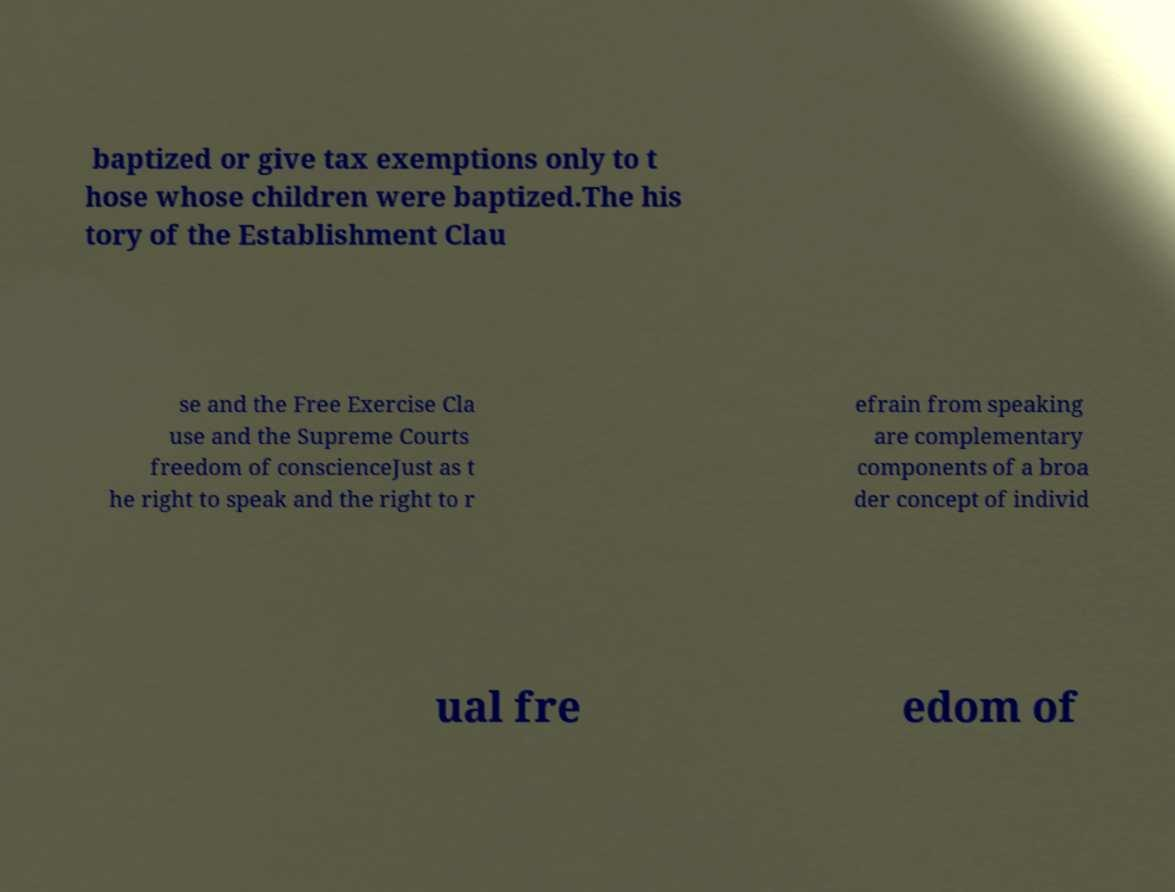Please identify and transcribe the text found in this image. baptized or give tax exemptions only to t hose whose children were baptized.The his tory of the Establishment Clau se and the Free Exercise Cla use and the Supreme Courts freedom of conscienceJust as t he right to speak and the right to r efrain from speaking are complementary components of a broa der concept of individ ual fre edom of 